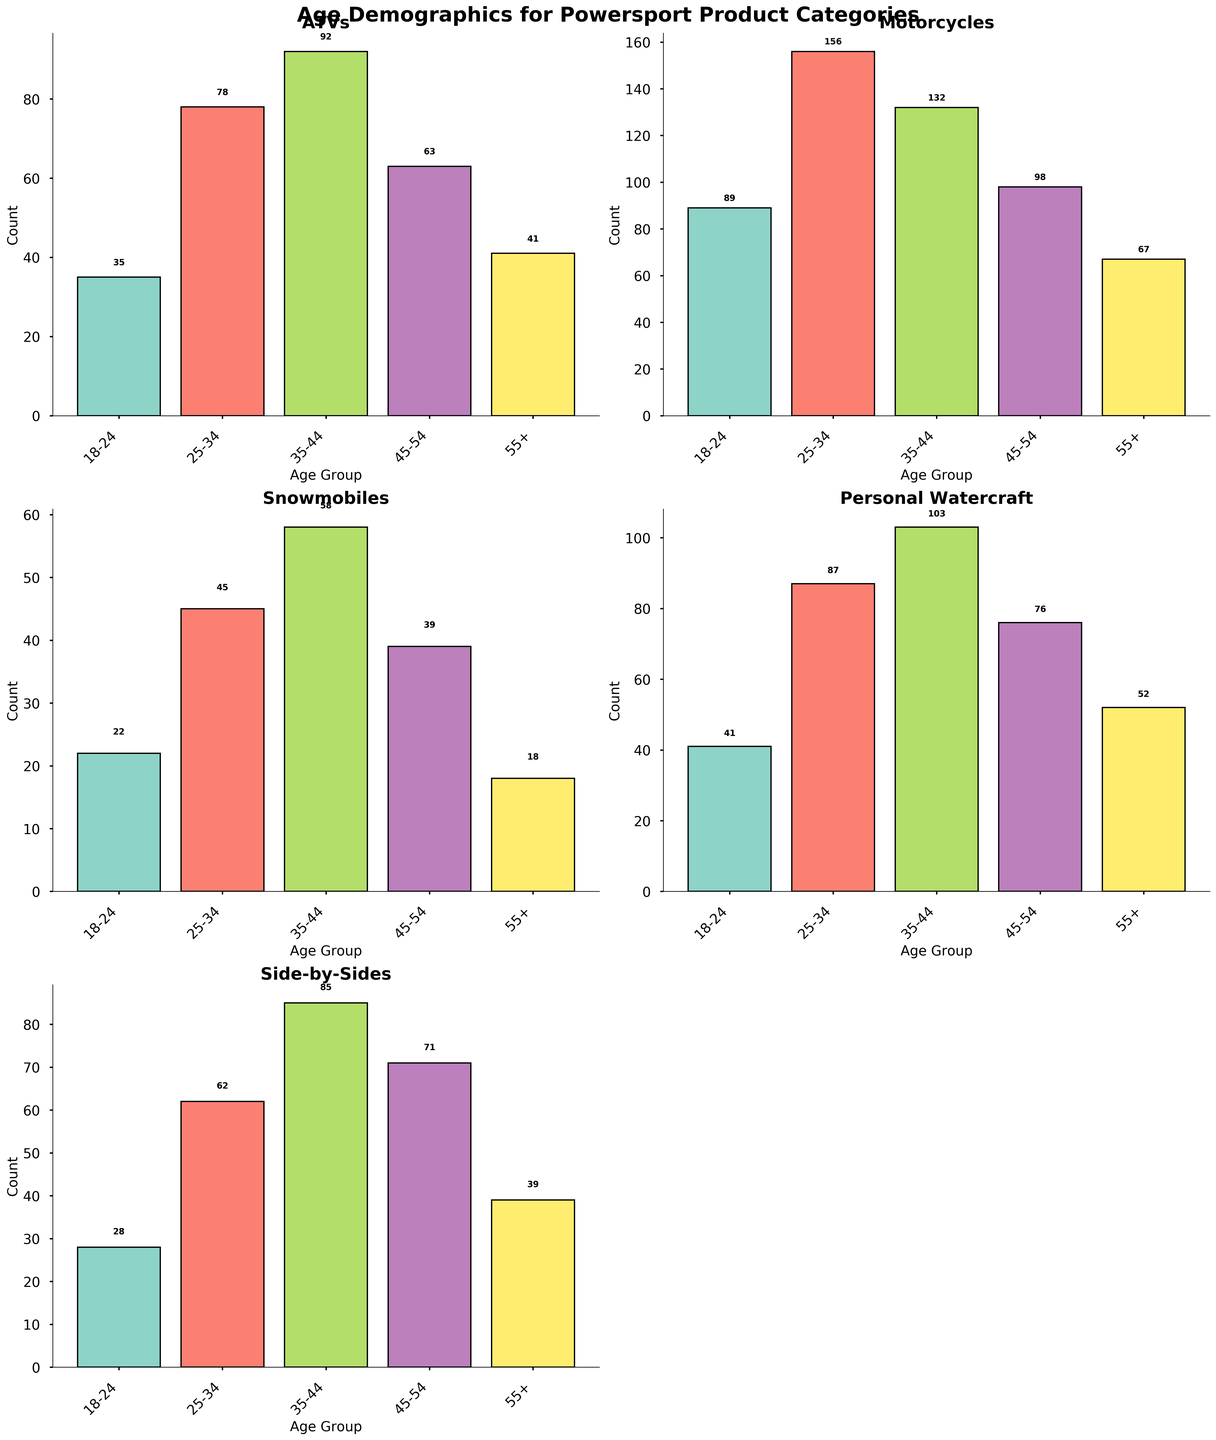What is the title of the figure? The title is at the top of the figure and reads "Age Demographics for Powersport Product Categories".
Answer: Age Demographics for Powersport Product Categories How many age groups are represented in the histogram for ATVs? The x-axis of the ATVs subplot shows the age groups, which are 18-24, 25-34, 35-44, 45-54, and 55+.
Answer: 5 Which product category has the highest count in the 18-24 age group? Look at the 18-24 age group bar in each subplot and compare the heights. Motorcycles have the highest count, with a value of 89.
Answer: Motorcycles What is the total count for all age groups in the Snowmobiles category? Add the counts for all age groups in the Snowmobiles subplot (22 + 45 + 58 + 39 + 18).
Answer: 182 What product category shows the lowest count in the 55+ age group? Look at the 55+ age group bar in each subplot and find the one with the lowest height, which is Snowmobiles with a count of 18.
Answer: Snowmobiles Which product category has the largest difference in counts between the 25-34 and 35-44 age groups? Find the difference for each category: ATVs (92 - 78 = 14), Motorcycles (132 - 156 = -24), Snowmobiles (58 - 45 = 13), Personal Watercraft (103 - 87 = 16), Side-by-Sides (85 - 62 = 23). The largest difference is for Side-by-Sides (23).
Answer: Side-by-Sides What is the combined count of customers aged 45-54 for all product categories? Add the counts for the 45-54 age group in each subplot (63 + 98 + 39 + 76 + 71).
Answer: 347 Which two age groups in the Motorcycle category have the smallest difference in counts? Calculate differences between consecutive age groups: 25-34 vs 18-24 (156 - 89 = 67), 35-44 vs 25-34 (132 - 156 = -24), 45-54 vs 35-44 (98 - 132 = -34), 55+ vs 45-54 (67 - 98 = -31). The smallest difference is between the 45-54 and 55+ groups with a difference of 31.
Answer: 45-54 and 55+ Which product category appears to have the most evenly distributed customer age demographics? Look for the category where the bar heights are most uniform across age groups. Side-by-Sides have relatively uniform heights compared to the other categories.
Answer: Side-by-Sides 